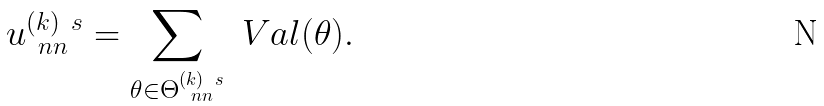Convert formula to latex. <formula><loc_0><loc_0><loc_500><loc_500>u ^ { ( k ) \ s } _ { \ n n } = \sum _ { \theta \in \Theta _ { \ n n } ^ { ( k ) \ s } } \ V a l ( \theta ) .</formula> 